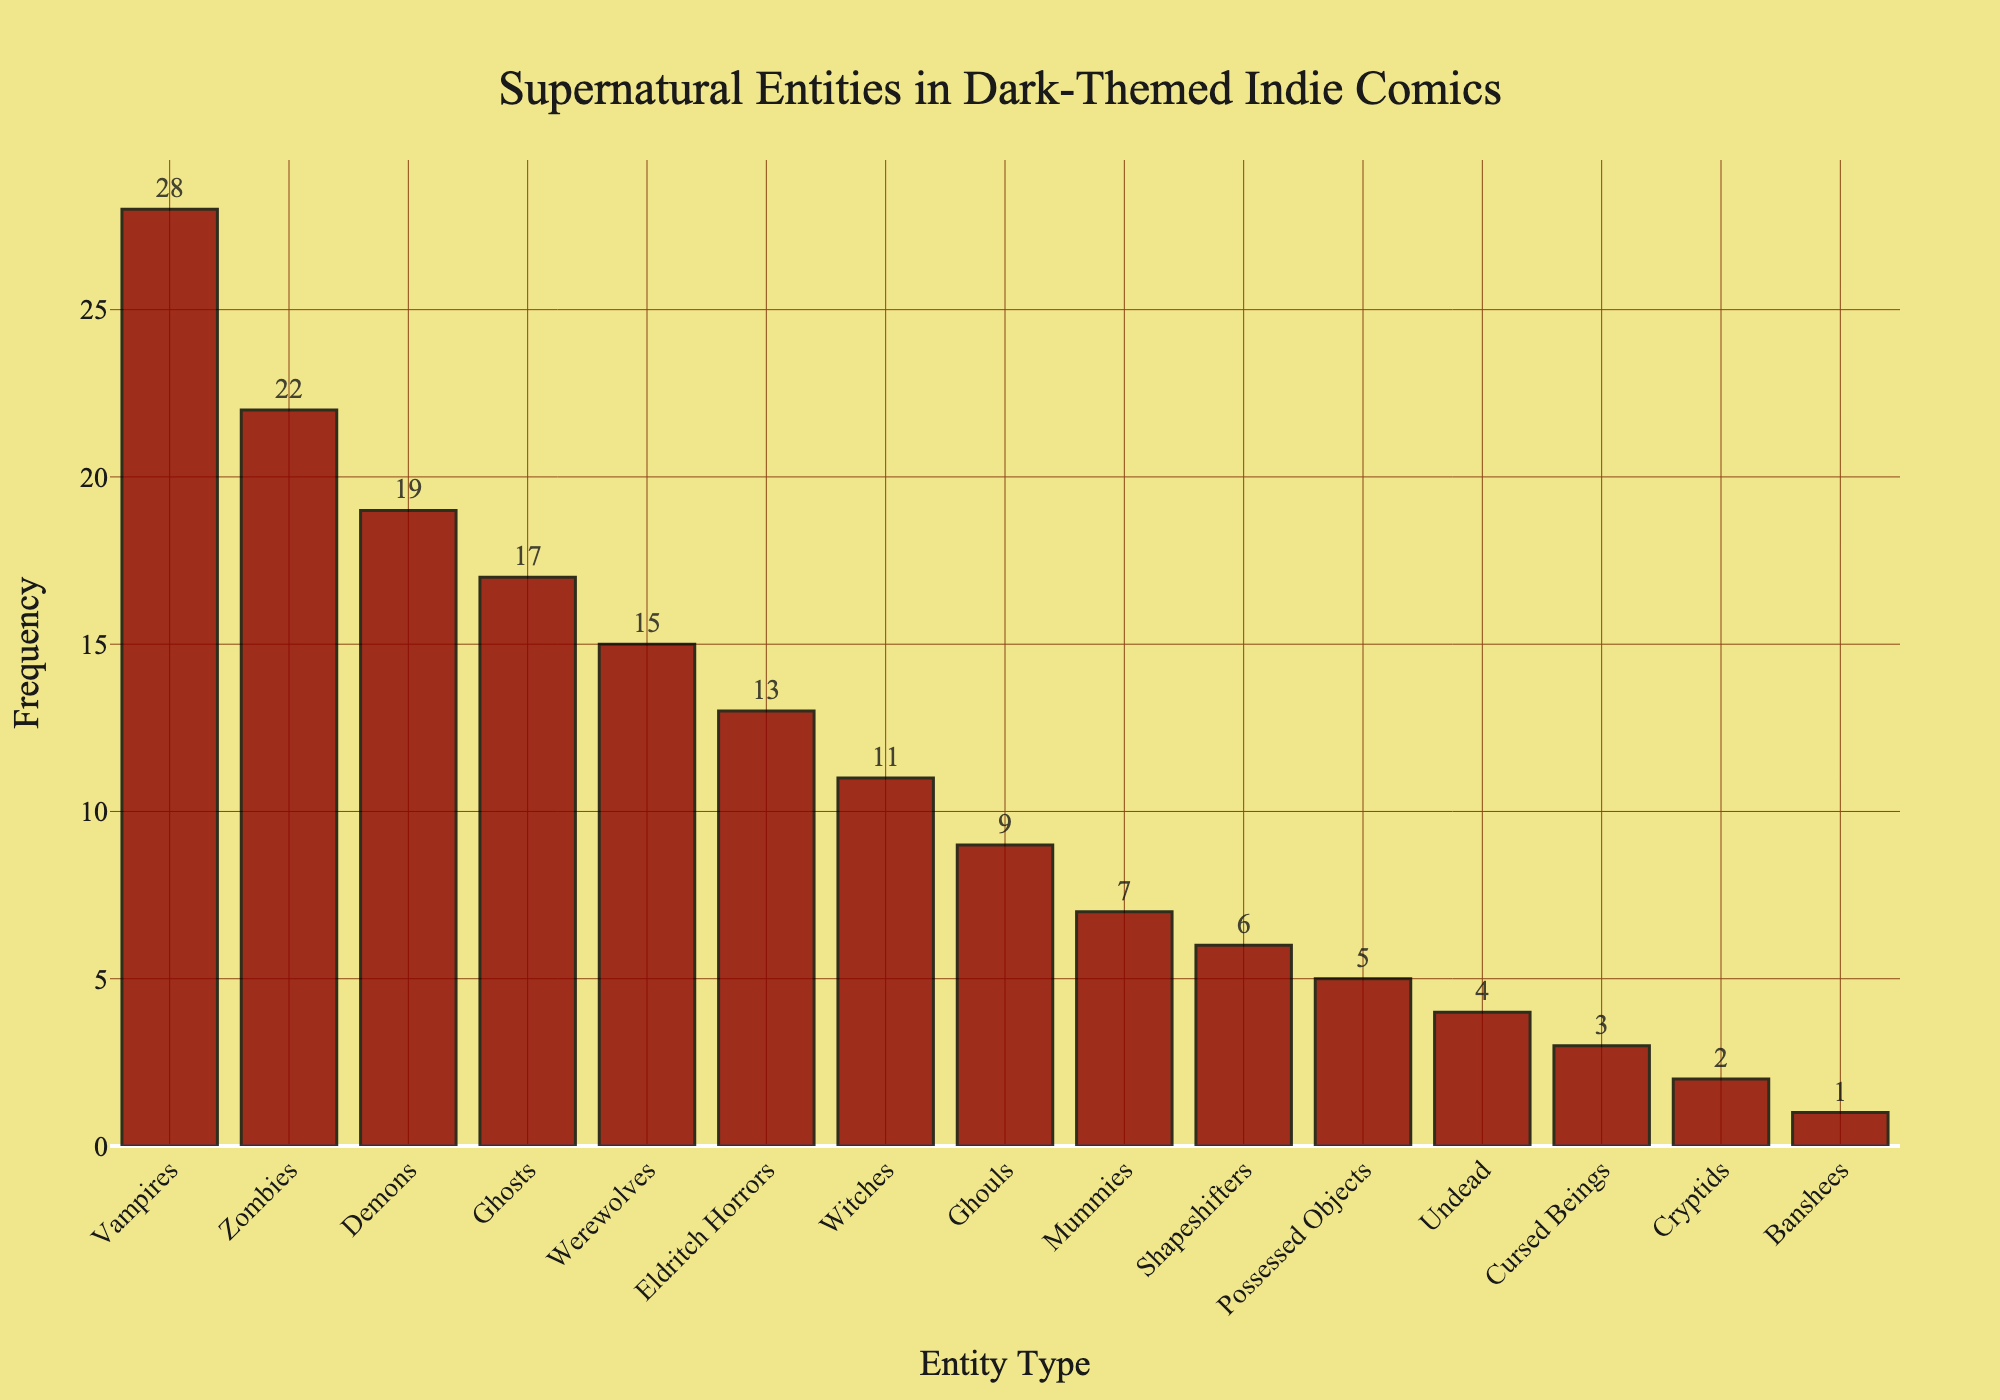Which supernatural entity featured in dark-themed indie comics is the most common? The bar representing vampires is the tallest, indicating it is the most frequent.
Answer: Vampires How many more times do vampires appear compared to zombies? Refer to the heights of the bars for vampires and zombies. Vampires have a frequency of 28, zombies have 22. Subtract the frequency of zombies from vampires: 28 - 22 = 6.
Answer: 6 Which supernatural entities have a frequency greater than 15? Observing the bars, the entities with frequencies greater than 15 are Vampires (28), Zombies (22), Demons (19), and Ghosts (17).
Answer: Vampires, Zombies, Demons, Ghosts What is the total frequency of Eldritch Horrors and Witches? Eldritch Horrors appear 13 times and Witches 11 times. Add these two frequencies: 13 + 11 = 24.
Answer: 24 What is the average frequency of the three least common entities? The least common entities are Cryptids (2), Banshees (1), and Cursed Beings (3). Sum these frequencies and divide by 3: (2 + 1 + 3) / 3 = 6 / 3 = 2.
Answer: 2 Which supernatural entity appears least frequently? The bar that is the shortest represents Banshees, indicating it appears the least frequently.
Answer: Banshees How many supernatural entities have a frequency of less than 10? Count the bars with frequencies less than 10: Ghouls (9), Mummies (7), Shapeshifters (6), Possessed Objects (5), Undead (4), Cursed Beings (3), Cryptids (2), Banshees (1). There are 8 such bars.
Answer: 8 